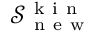Convert formula to latex. <formula><loc_0><loc_0><loc_500><loc_500>\mathcal { S } _ { n e w } ^ { k i n }</formula> 